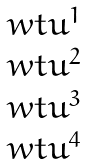<formula> <loc_0><loc_0><loc_500><loc_500>\begin{matrix} \ w t { u } ^ { 1 } \\ \ w t { u } ^ { 2 } \\ \ w t { u } ^ { 3 } \\ \ w t { u } ^ { 4 } \end{matrix}</formula> 